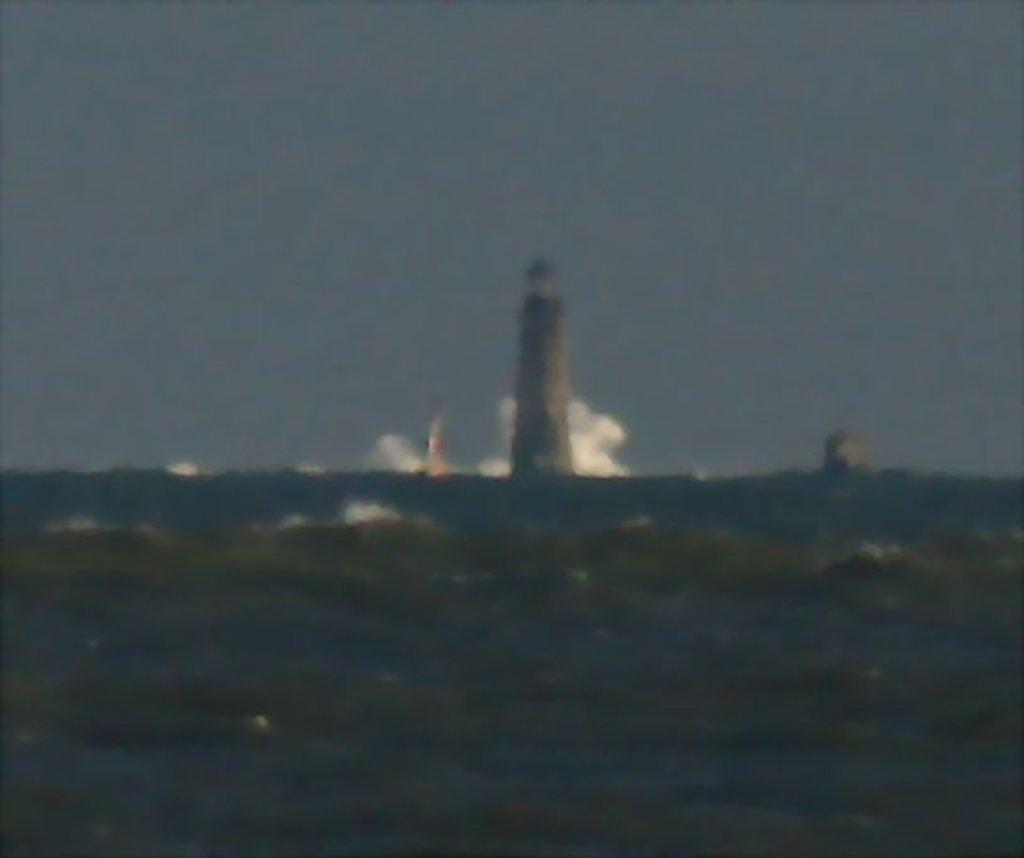What is the main feature of the image? The main feature of the image is a lighthouse. Where is the lighthouse located in the image? The lighthouse is in the middle of the image. What is the condition of the sky in the image? The sky is cloudy in the image. What is present in the image besides the lighthouse? There is water in the image. Can you see an arch connecting the lighthouse to the shore in the image? There is no arch connecting the lighthouse to the shore in the image. Is it summer in the image? The provided facts do not mention the season, so it cannot be determined from the image. 